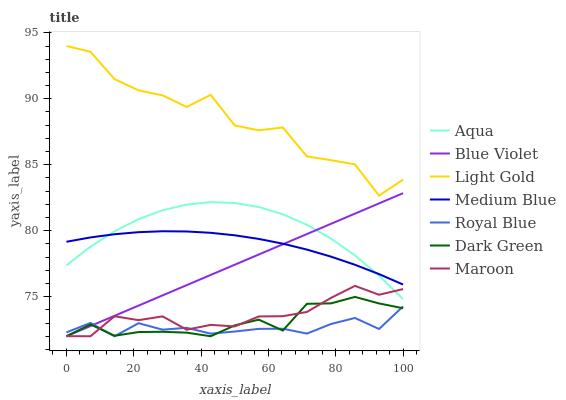Does Aqua have the minimum area under the curve?
Answer yes or no. No. Does Aqua have the maximum area under the curve?
Answer yes or no. No. Is Aqua the smoothest?
Answer yes or no. No. Is Aqua the roughest?
Answer yes or no. No. Does Aqua have the lowest value?
Answer yes or no. No. Does Aqua have the highest value?
Answer yes or no. No. Is Dark Green less than Medium Blue?
Answer yes or no. Yes. Is Light Gold greater than Maroon?
Answer yes or no. Yes. Does Dark Green intersect Medium Blue?
Answer yes or no. No. 